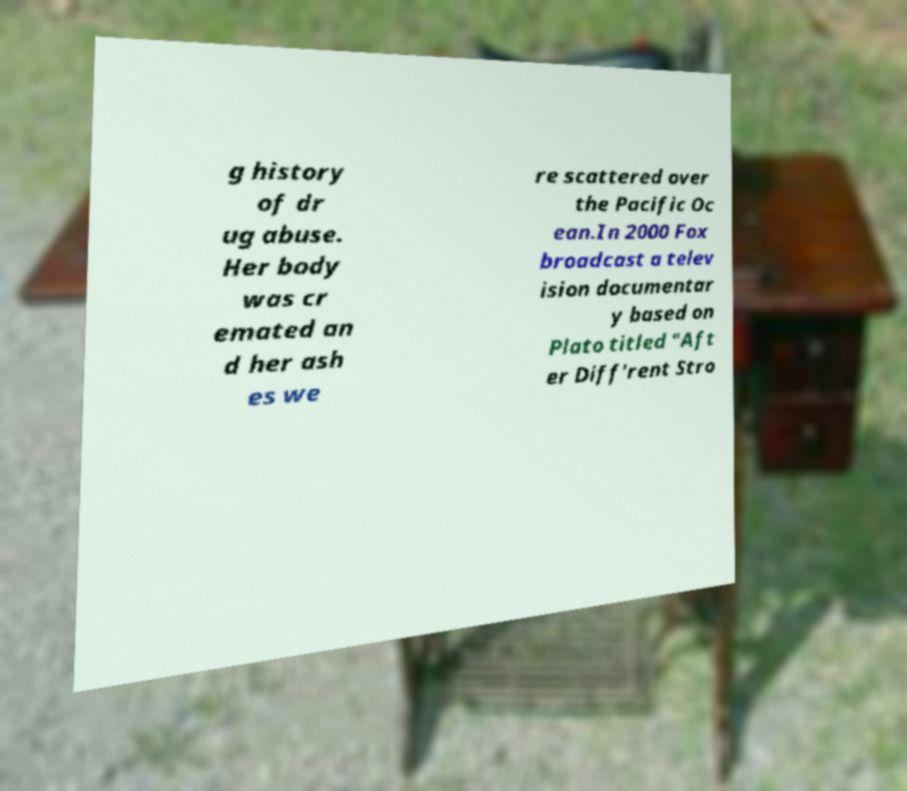There's text embedded in this image that I need extracted. Can you transcribe it verbatim? g history of dr ug abuse. Her body was cr emated an d her ash es we re scattered over the Pacific Oc ean.In 2000 Fox broadcast a telev ision documentar y based on Plato titled "Aft er Diff'rent Stro 